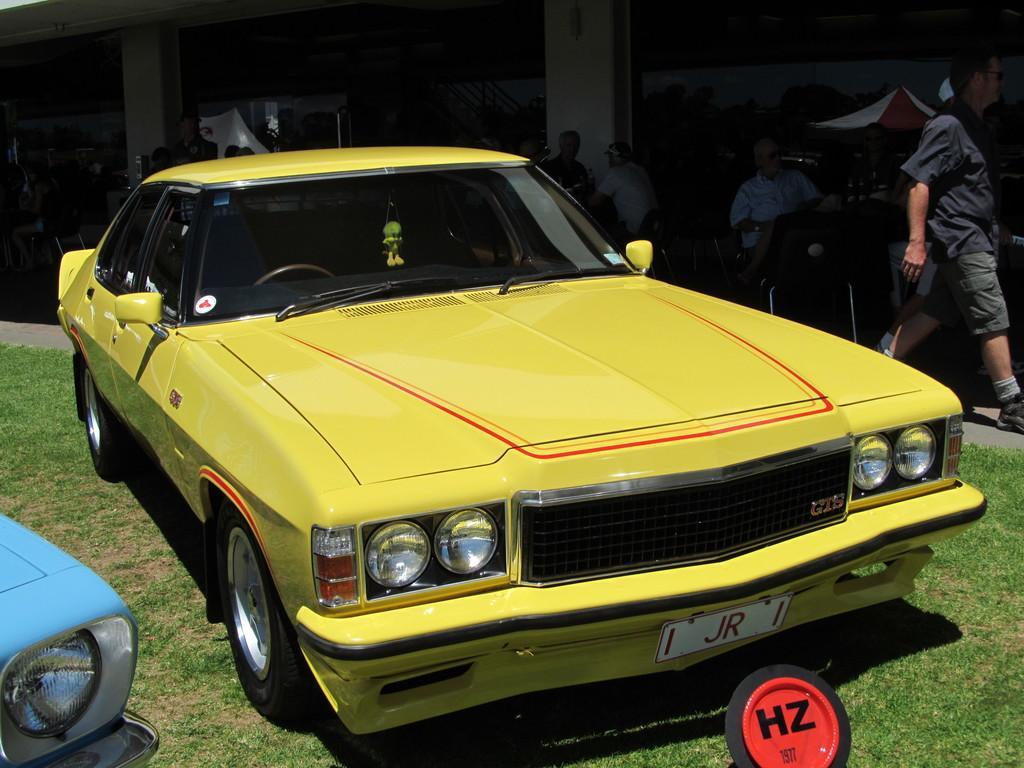Describe this image in one or two sentences. In this image there are cars on the ground. Beside the cars there are people sitting on the chair. At the back side there is a building. 